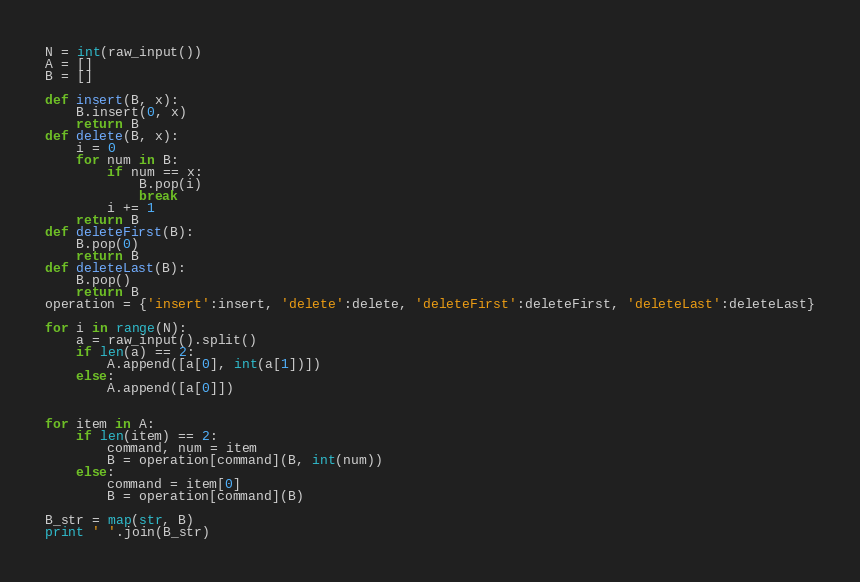<code> <loc_0><loc_0><loc_500><loc_500><_Python_>N = int(raw_input())
A = []
B = []

def insert(B, x):
    B.insert(0, x)
    return B
def delete(B, x):
    i = 0
    for num in B:
        if num == x:
            B.pop(i)
            break
        i += 1
    return B
def deleteFirst(B):
    B.pop(0)
    return B
def deleteLast(B):
    B.pop()
    return B
operation = {'insert':insert, 'delete':delete, 'deleteFirst':deleteFirst, 'deleteLast':deleteLast}

for i in range(N):
    a = raw_input().split()
    if len(a) == 2:
        A.append([a[0], int(a[1])])
    else:
        A.append([a[0]])


for item in A:
    if len(item) == 2:
        command, num = item
        B = operation[command](B, int(num))
    else:
        command = item[0]
        B = operation[command](B)

B_str = map(str, B)
print ' '.join(B_str)</code> 